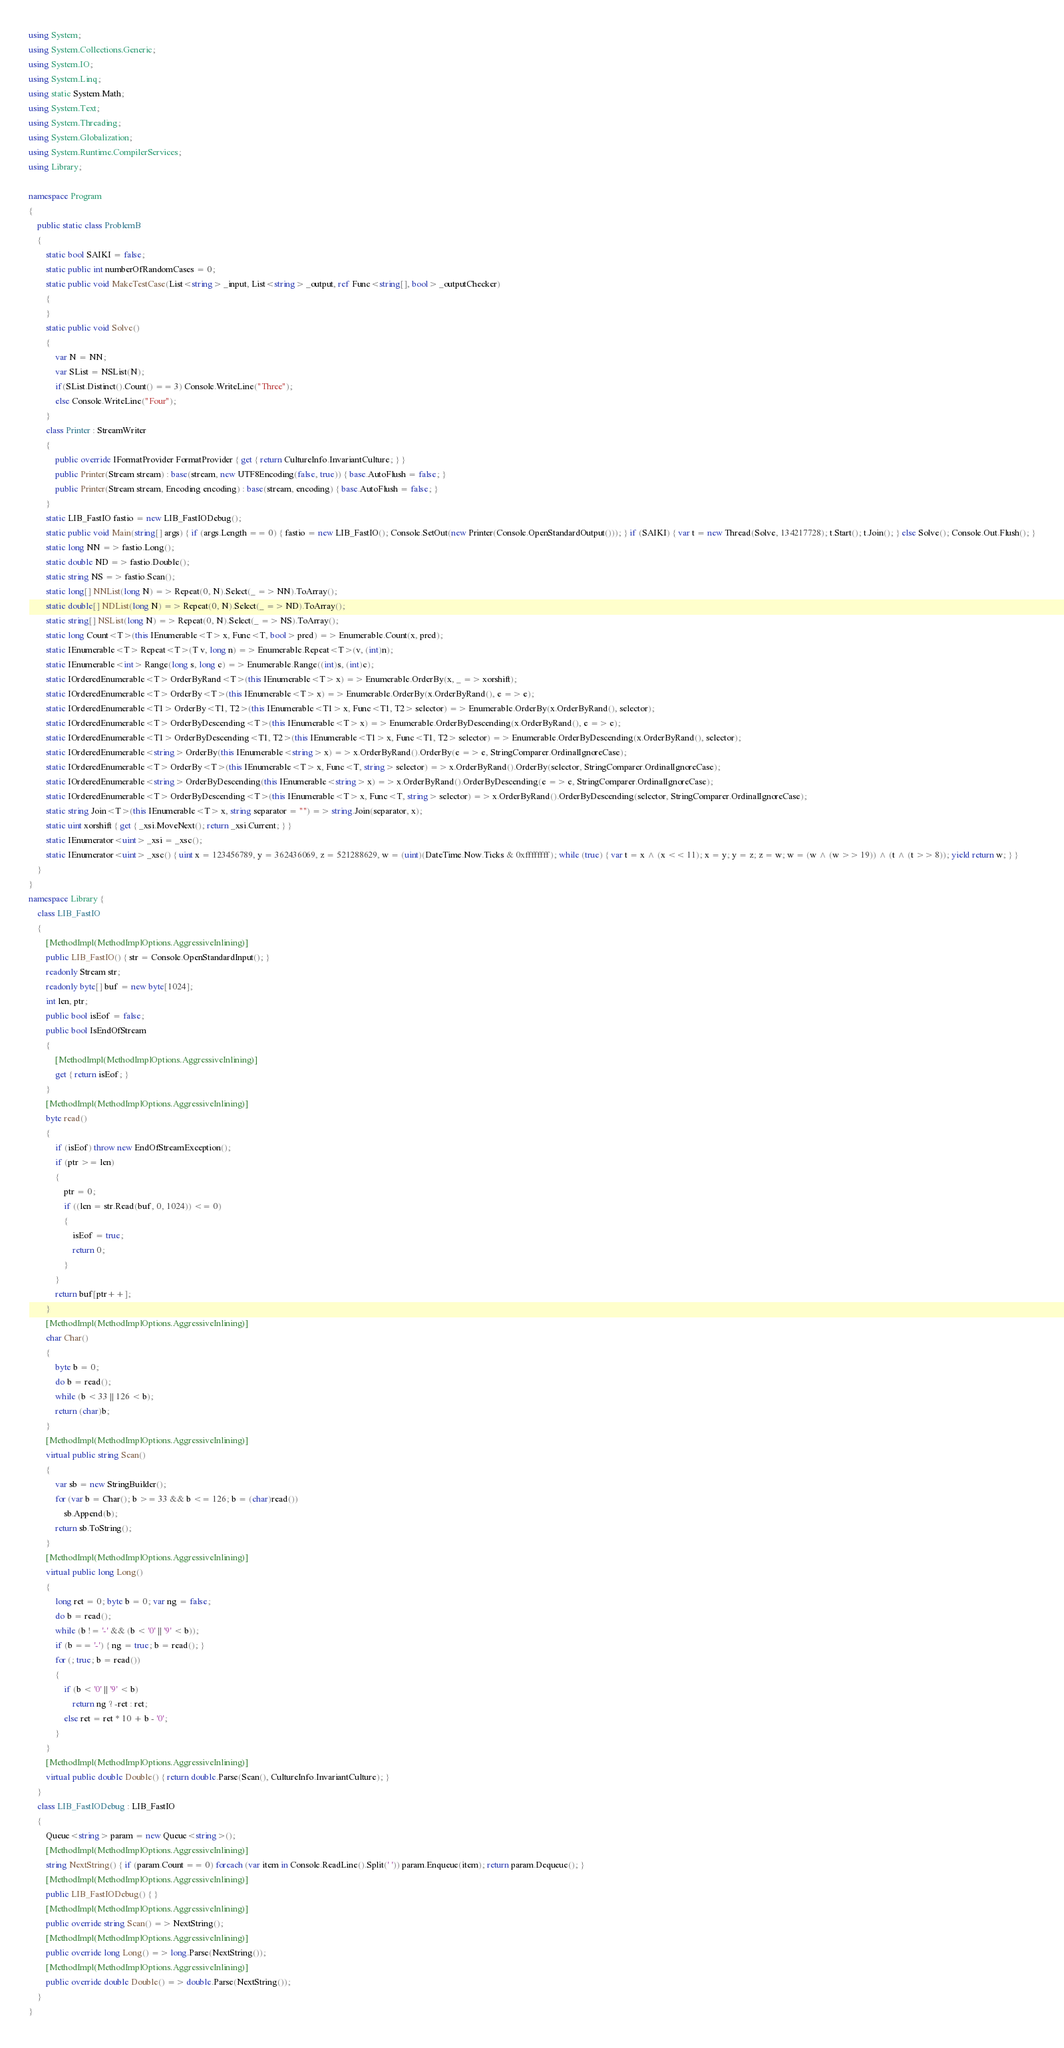<code> <loc_0><loc_0><loc_500><loc_500><_C#_>using System;
using System.Collections.Generic;
using System.IO;
using System.Linq;
using static System.Math;
using System.Text;
using System.Threading;
using System.Globalization;
using System.Runtime.CompilerServices;
using Library;

namespace Program
{
    public static class ProblemB
    {
        static bool SAIKI = false;
        static public int numberOfRandomCases = 0;
        static public void MakeTestCase(List<string> _input, List<string> _output, ref Func<string[], bool> _outputChecker)
        {
        }
        static public void Solve()
        {
            var N = NN;
            var SList = NSList(N);
            if(SList.Distinct().Count() == 3) Console.WriteLine("Three");
            else Console.WriteLine("Four");
        }
        class Printer : StreamWriter
        {
            public override IFormatProvider FormatProvider { get { return CultureInfo.InvariantCulture; } }
            public Printer(Stream stream) : base(stream, new UTF8Encoding(false, true)) { base.AutoFlush = false; }
            public Printer(Stream stream, Encoding encoding) : base(stream, encoding) { base.AutoFlush = false; }
        }
        static LIB_FastIO fastio = new LIB_FastIODebug();
        static public void Main(string[] args) { if (args.Length == 0) { fastio = new LIB_FastIO(); Console.SetOut(new Printer(Console.OpenStandardOutput())); } if (SAIKI) { var t = new Thread(Solve, 134217728); t.Start(); t.Join(); } else Solve(); Console.Out.Flush(); }
        static long NN => fastio.Long();
        static double ND => fastio.Double();
        static string NS => fastio.Scan();
        static long[] NNList(long N) => Repeat(0, N).Select(_ => NN).ToArray();
        static double[] NDList(long N) => Repeat(0, N).Select(_ => ND).ToArray();
        static string[] NSList(long N) => Repeat(0, N).Select(_ => NS).ToArray();
        static long Count<T>(this IEnumerable<T> x, Func<T, bool> pred) => Enumerable.Count(x, pred);
        static IEnumerable<T> Repeat<T>(T v, long n) => Enumerable.Repeat<T>(v, (int)n);
        static IEnumerable<int> Range(long s, long c) => Enumerable.Range((int)s, (int)c);
        static IOrderedEnumerable<T> OrderByRand<T>(this IEnumerable<T> x) => Enumerable.OrderBy(x, _ => xorshift);
        static IOrderedEnumerable<T> OrderBy<T>(this IEnumerable<T> x) => Enumerable.OrderBy(x.OrderByRand(), e => e);
        static IOrderedEnumerable<T1> OrderBy<T1, T2>(this IEnumerable<T1> x, Func<T1, T2> selector) => Enumerable.OrderBy(x.OrderByRand(), selector);
        static IOrderedEnumerable<T> OrderByDescending<T>(this IEnumerable<T> x) => Enumerable.OrderByDescending(x.OrderByRand(), e => e);
        static IOrderedEnumerable<T1> OrderByDescending<T1, T2>(this IEnumerable<T1> x, Func<T1, T2> selector) => Enumerable.OrderByDescending(x.OrderByRand(), selector);
        static IOrderedEnumerable<string> OrderBy(this IEnumerable<string> x) => x.OrderByRand().OrderBy(e => e, StringComparer.OrdinalIgnoreCase);
        static IOrderedEnumerable<T> OrderBy<T>(this IEnumerable<T> x, Func<T, string> selector) => x.OrderByRand().OrderBy(selector, StringComparer.OrdinalIgnoreCase);
        static IOrderedEnumerable<string> OrderByDescending(this IEnumerable<string> x) => x.OrderByRand().OrderByDescending(e => e, StringComparer.OrdinalIgnoreCase);
        static IOrderedEnumerable<T> OrderByDescending<T>(this IEnumerable<T> x, Func<T, string> selector) => x.OrderByRand().OrderByDescending(selector, StringComparer.OrdinalIgnoreCase);
        static string Join<T>(this IEnumerable<T> x, string separator = "") => string.Join(separator, x);
        static uint xorshift { get { _xsi.MoveNext(); return _xsi.Current; } }
        static IEnumerator<uint> _xsi = _xsc();
        static IEnumerator<uint> _xsc() { uint x = 123456789, y = 362436069, z = 521288629, w = (uint)(DateTime.Now.Ticks & 0xffffffff); while (true) { var t = x ^ (x << 11); x = y; y = z; z = w; w = (w ^ (w >> 19)) ^ (t ^ (t >> 8)); yield return w; } }
    }
}
namespace Library {
    class LIB_FastIO
    {
        [MethodImpl(MethodImplOptions.AggressiveInlining)]
        public LIB_FastIO() { str = Console.OpenStandardInput(); }
        readonly Stream str;
        readonly byte[] buf = new byte[1024];
        int len, ptr;
        public bool isEof = false;
        public bool IsEndOfStream
        {
            [MethodImpl(MethodImplOptions.AggressiveInlining)]
            get { return isEof; }
        }
        [MethodImpl(MethodImplOptions.AggressiveInlining)]
        byte read()
        {
            if (isEof) throw new EndOfStreamException();
            if (ptr >= len)
            {
                ptr = 0;
                if ((len = str.Read(buf, 0, 1024)) <= 0)
                {
                    isEof = true;
                    return 0;
                }
            }
            return buf[ptr++];
        }
        [MethodImpl(MethodImplOptions.AggressiveInlining)]
        char Char()
        {
            byte b = 0;
            do b = read();
            while (b < 33 || 126 < b);
            return (char)b;
        }
        [MethodImpl(MethodImplOptions.AggressiveInlining)]
        virtual public string Scan()
        {
            var sb = new StringBuilder();
            for (var b = Char(); b >= 33 && b <= 126; b = (char)read())
                sb.Append(b);
            return sb.ToString();
        }
        [MethodImpl(MethodImplOptions.AggressiveInlining)]
        virtual public long Long()
        {
            long ret = 0; byte b = 0; var ng = false;
            do b = read();
            while (b != '-' && (b < '0' || '9' < b));
            if (b == '-') { ng = true; b = read(); }
            for (; true; b = read())
            {
                if (b < '0' || '9' < b)
                    return ng ? -ret : ret;
                else ret = ret * 10 + b - '0';
            }
        }
        [MethodImpl(MethodImplOptions.AggressiveInlining)]
        virtual public double Double() { return double.Parse(Scan(), CultureInfo.InvariantCulture); }
    }
    class LIB_FastIODebug : LIB_FastIO
    {
        Queue<string> param = new Queue<string>();
        [MethodImpl(MethodImplOptions.AggressiveInlining)]
        string NextString() { if (param.Count == 0) foreach (var item in Console.ReadLine().Split(' ')) param.Enqueue(item); return param.Dequeue(); }
        [MethodImpl(MethodImplOptions.AggressiveInlining)]
        public LIB_FastIODebug() { }
        [MethodImpl(MethodImplOptions.AggressiveInlining)]
        public override string Scan() => NextString();
        [MethodImpl(MethodImplOptions.AggressiveInlining)]
        public override long Long() => long.Parse(NextString());
        [MethodImpl(MethodImplOptions.AggressiveInlining)]
        public override double Double() => double.Parse(NextString());
    }
}
</code> 